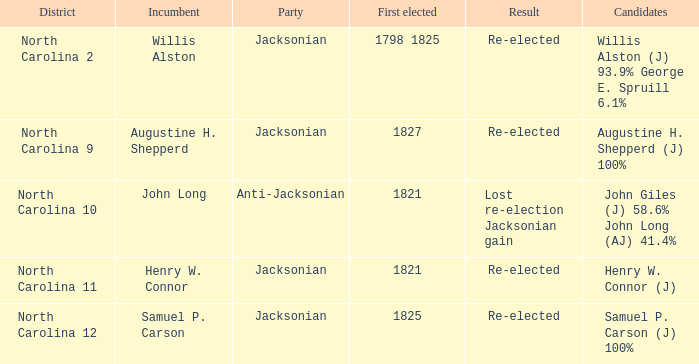Name the district for anti-jacksonian North Carolina 10. Help me parse the entirety of this table. {'header': ['District', 'Incumbent', 'Party', 'First elected', 'Result', 'Candidates'], 'rows': [['North Carolina 2', 'Willis Alston', 'Jacksonian', '1798 1825', 'Re-elected', 'Willis Alston (J) 93.9% George E. Spruill 6.1%'], ['North Carolina 9', 'Augustine H. Shepperd', 'Jacksonian', '1827', 'Re-elected', 'Augustine H. Shepperd (J) 100%'], ['North Carolina 10', 'John Long', 'Anti-Jacksonian', '1821', 'Lost re-election Jacksonian gain', 'John Giles (J) 58.6% John Long (AJ) 41.4%'], ['North Carolina 11', 'Henry W. Connor', 'Jacksonian', '1821', 'Re-elected', 'Henry W. Connor (J)'], ['North Carolina 12', 'Samuel P. Carson', 'Jacksonian', '1825', 'Re-elected', 'Samuel P. Carson (J) 100%']]} 